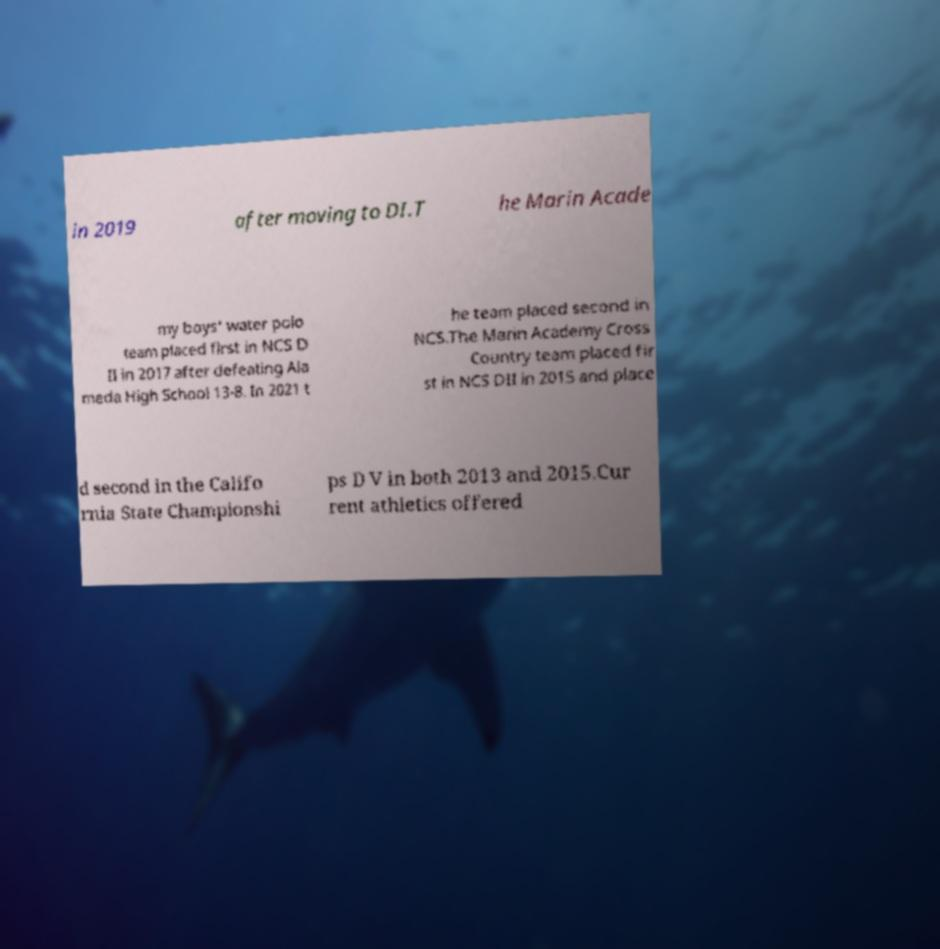For documentation purposes, I need the text within this image transcribed. Could you provide that? in 2019 after moving to DI.T he Marin Acade my boys' water polo team placed first in NCS D II in 2017 after defeating Ala meda High School 13-8. In 2021 t he team placed second in NCS.The Marin Academy Cross Country team placed fir st in NCS DII in 2015 and place d second in the Califo rnia State Championshi ps D V in both 2013 and 2015.Cur rent athletics offered 